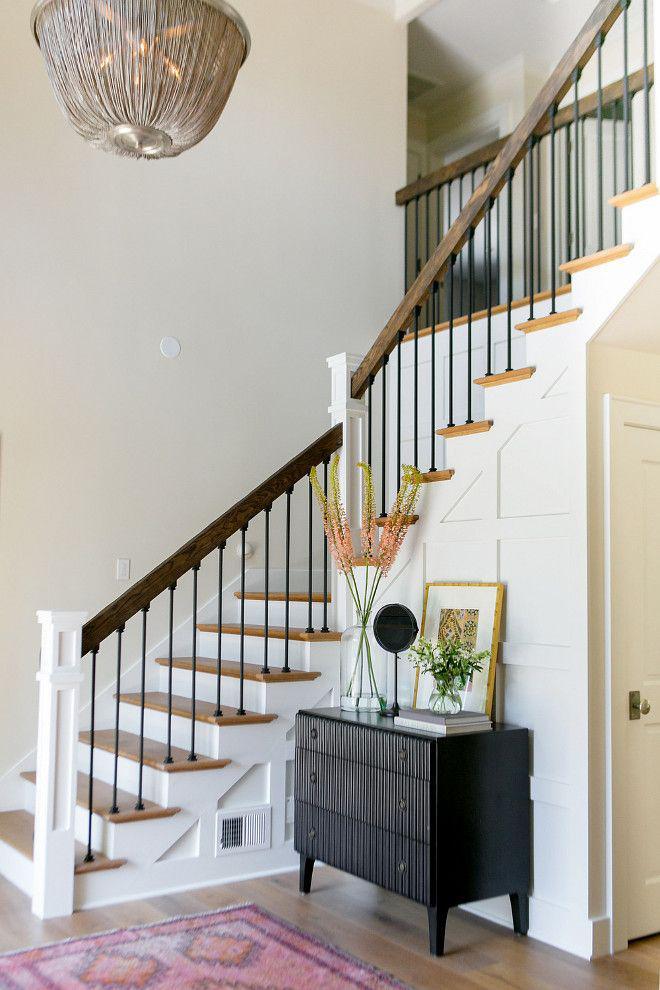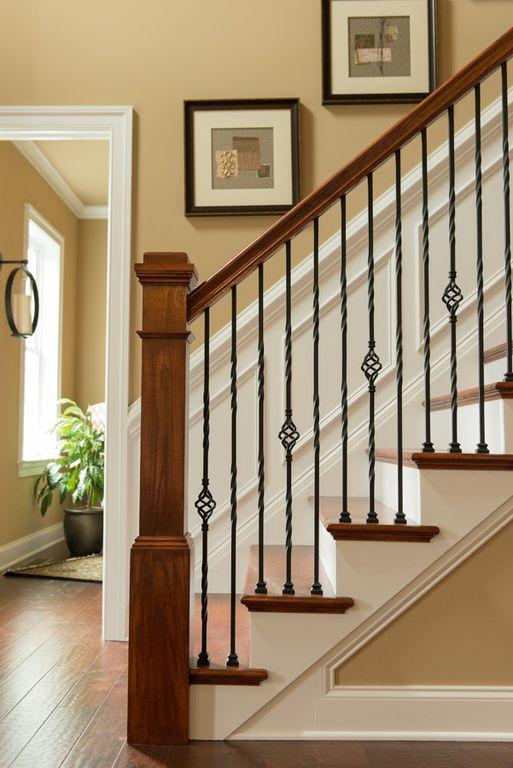The first image is the image on the left, the second image is the image on the right. Given the left and right images, does the statement "In at least one of the images, the piece of furniture near the bottom of the stairs has a vase of flowers on it." hold true? Answer yes or no. Yes. The first image is the image on the left, the second image is the image on the right. Given the left and right images, does the statement "Framed pictures follow the line of the stairway in the image on the right." hold true? Answer yes or no. Yes. 